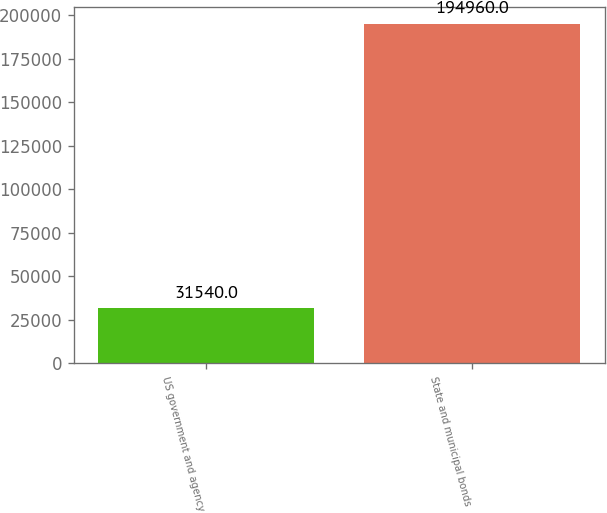Convert chart to OTSL. <chart><loc_0><loc_0><loc_500><loc_500><bar_chart><fcel>US government and agency<fcel>State and municipal bonds<nl><fcel>31540<fcel>194960<nl></chart> 